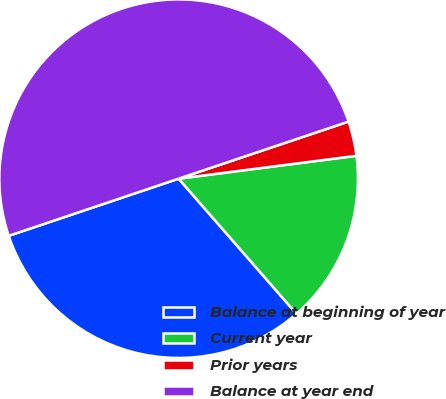Convert chart. <chart><loc_0><loc_0><loc_500><loc_500><pie_chart><fcel>Balance at beginning of year<fcel>Current year<fcel>Prior years<fcel>Balance at year end<nl><fcel>31.25%<fcel>15.62%<fcel>3.12%<fcel>50.0%<nl></chart> 